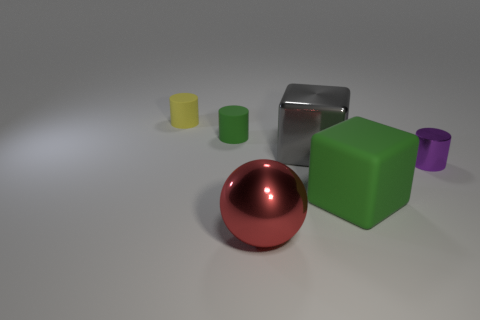Can you describe the arrangement of objects in the image? Certainly! The image displays a collection of geometric objects on a flat surface. In the foreground, there is a shiny red metallic sphere. Behind it, to the left, a matte green cube is visible, along with a small yellow cylinder. Behind the sphere and slightly to the right, there is a large reflective metallic cube. All the objects are placed against a neutral background. 